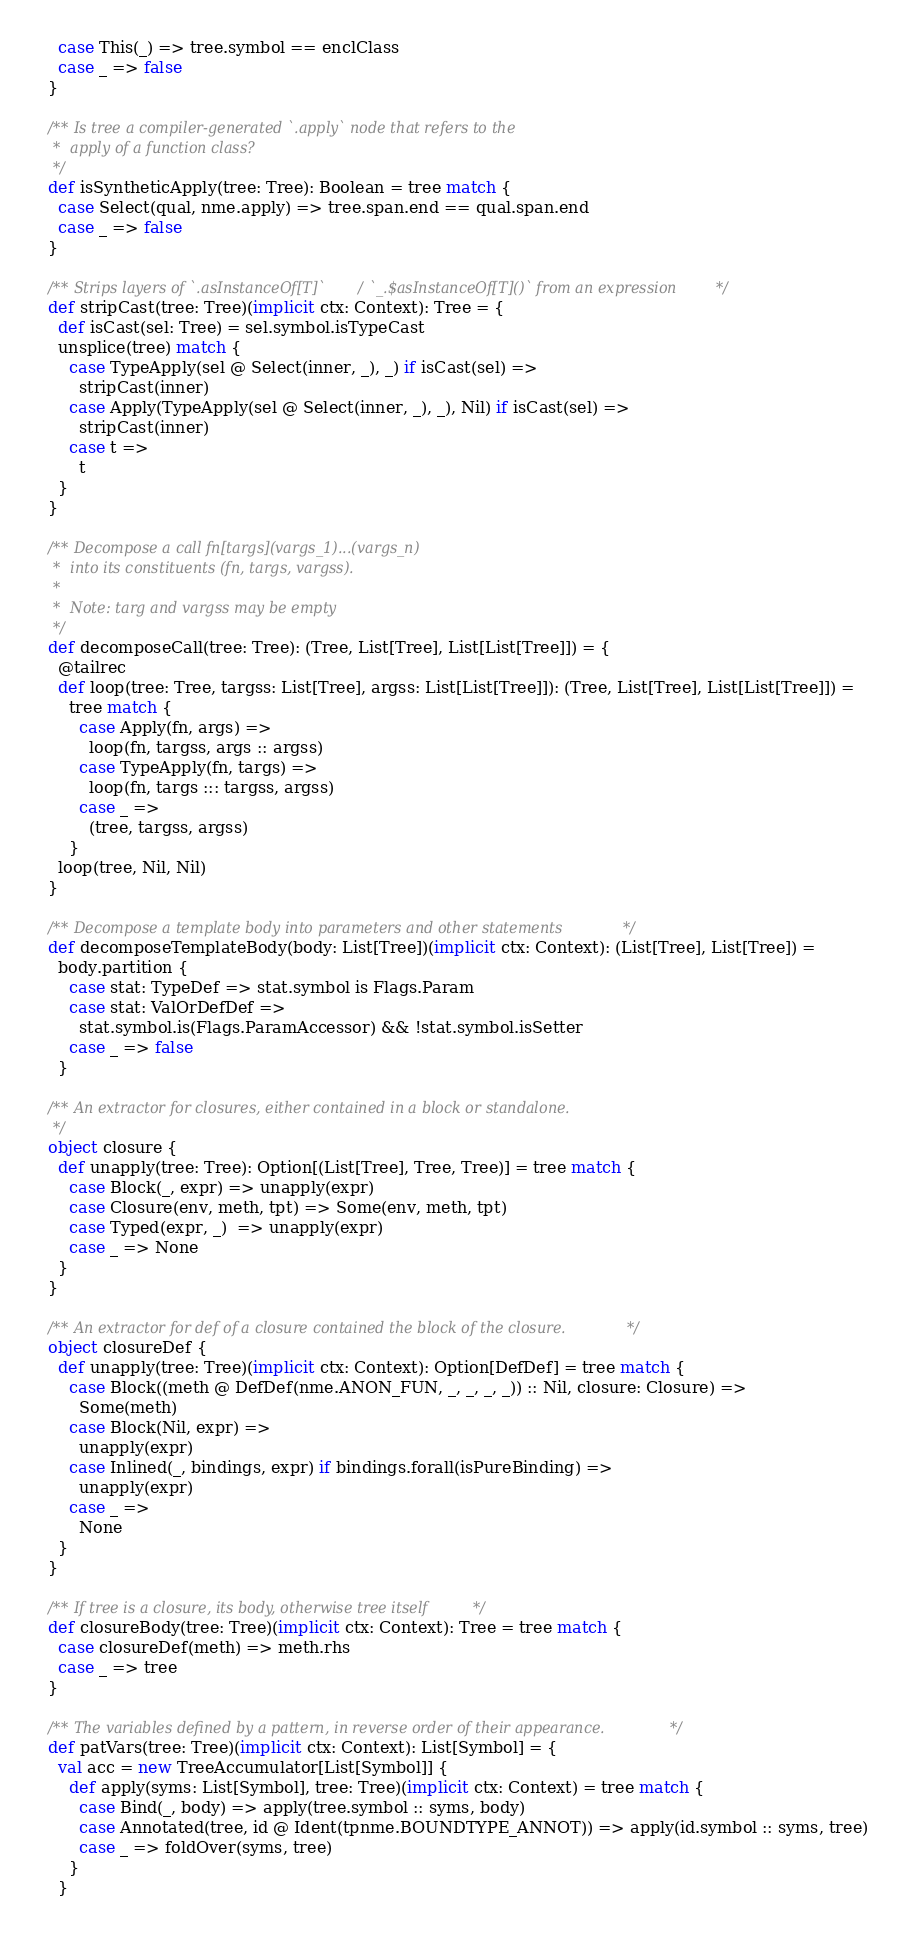<code> <loc_0><loc_0><loc_500><loc_500><_Scala_>    case This(_) => tree.symbol == enclClass
    case _ => false
  }

  /** Is tree a compiler-generated `.apply` node that refers to the
   *  apply of a function class?
   */
  def isSyntheticApply(tree: Tree): Boolean = tree match {
    case Select(qual, nme.apply) => tree.span.end == qual.span.end
    case _ => false
  }

  /** Strips layers of `.asInstanceOf[T]` / `_.$asInstanceOf[T]()` from an expression */
  def stripCast(tree: Tree)(implicit ctx: Context): Tree = {
    def isCast(sel: Tree) = sel.symbol.isTypeCast
    unsplice(tree) match {
      case TypeApply(sel @ Select(inner, _), _) if isCast(sel) =>
        stripCast(inner)
      case Apply(TypeApply(sel @ Select(inner, _), _), Nil) if isCast(sel) =>
        stripCast(inner)
      case t =>
        t
    }
  }

  /** Decompose a call fn[targs](vargs_1)...(vargs_n)
   *  into its constituents (fn, targs, vargss).
   *
   *  Note: targ and vargss may be empty
   */
  def decomposeCall(tree: Tree): (Tree, List[Tree], List[List[Tree]]) = {
    @tailrec
    def loop(tree: Tree, targss: List[Tree], argss: List[List[Tree]]): (Tree, List[Tree], List[List[Tree]]) =
      tree match {
        case Apply(fn, args) =>
          loop(fn, targss, args :: argss)
        case TypeApply(fn, targs) =>
          loop(fn, targs ::: targss, argss)
        case _ =>
          (tree, targss, argss)
      }
    loop(tree, Nil, Nil)
  }

  /** Decompose a template body into parameters and other statements */
  def decomposeTemplateBody(body: List[Tree])(implicit ctx: Context): (List[Tree], List[Tree]) =
    body.partition {
      case stat: TypeDef => stat.symbol is Flags.Param
      case stat: ValOrDefDef =>
        stat.symbol.is(Flags.ParamAccessor) && !stat.symbol.isSetter
      case _ => false
    }

  /** An extractor for closures, either contained in a block or standalone.
   */
  object closure {
    def unapply(tree: Tree): Option[(List[Tree], Tree, Tree)] = tree match {
      case Block(_, expr) => unapply(expr)
      case Closure(env, meth, tpt) => Some(env, meth, tpt)
      case Typed(expr, _)  => unapply(expr)
      case _ => None
    }
  }

  /** An extractor for def of a closure contained the block of the closure. */
  object closureDef {
    def unapply(tree: Tree)(implicit ctx: Context): Option[DefDef] = tree match {
      case Block((meth @ DefDef(nme.ANON_FUN, _, _, _, _)) :: Nil, closure: Closure) =>
        Some(meth)
      case Block(Nil, expr) =>
        unapply(expr)
      case Inlined(_, bindings, expr) if bindings.forall(isPureBinding) =>
        unapply(expr)
      case _ =>
        None
    }
  }

  /** If tree is a closure, its body, otherwise tree itself */
  def closureBody(tree: Tree)(implicit ctx: Context): Tree = tree match {
    case closureDef(meth) => meth.rhs
    case _ => tree
  }

  /** The variables defined by a pattern, in reverse order of their appearance. */
  def patVars(tree: Tree)(implicit ctx: Context): List[Symbol] = {
    val acc = new TreeAccumulator[List[Symbol]] {
      def apply(syms: List[Symbol], tree: Tree)(implicit ctx: Context) = tree match {
        case Bind(_, body) => apply(tree.symbol :: syms, body)
        case Annotated(tree, id @ Ident(tpnme.BOUNDTYPE_ANNOT)) => apply(id.symbol :: syms, tree)
        case _ => foldOver(syms, tree)
      }
    }</code> 